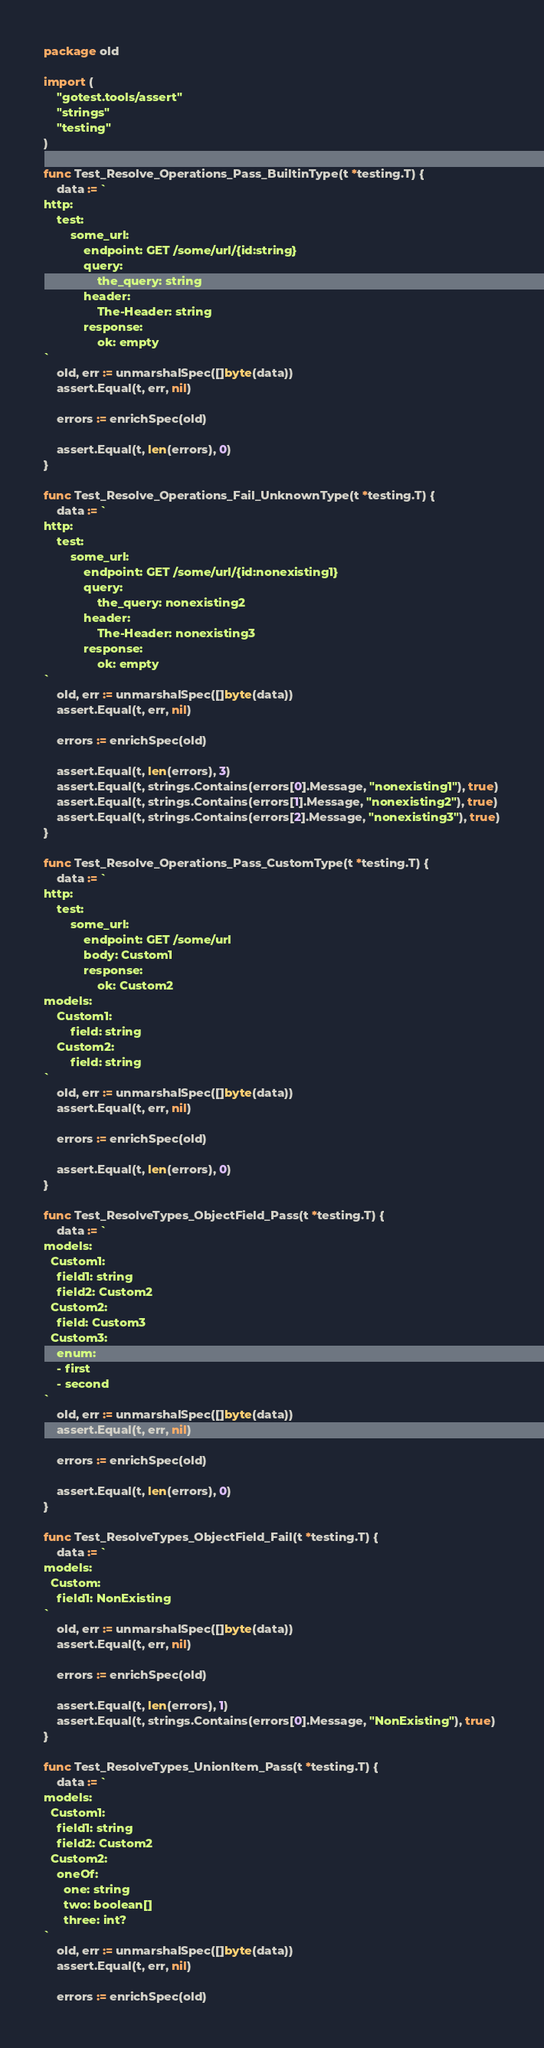<code> <loc_0><loc_0><loc_500><loc_500><_Go_>package old

import (
	"gotest.tools/assert"
	"strings"
	"testing"
)

func Test_Resolve_Operations_Pass_BuiltinType(t *testing.T) {
	data := `
http:
    test:
        some_url:
            endpoint: GET /some/url/{id:string}
            query:
                the_query: string
            header:
                The-Header: string
            response:
                ok: empty
`
	old, err := unmarshalSpec([]byte(data))
	assert.Equal(t, err, nil)

	errors := enrichSpec(old)

	assert.Equal(t, len(errors), 0)
}

func Test_Resolve_Operations_Fail_UnknownType(t *testing.T) {
	data := `
http:
    test:
        some_url:
            endpoint: GET /some/url/{id:nonexisting1}
            query:
                the_query: nonexisting2
            header:
                The-Header: nonexisting3
            response:
                ok: empty
`
	old, err := unmarshalSpec([]byte(data))
	assert.Equal(t, err, nil)

	errors := enrichSpec(old)

	assert.Equal(t, len(errors), 3)
	assert.Equal(t, strings.Contains(errors[0].Message, "nonexisting1"), true)
	assert.Equal(t, strings.Contains(errors[1].Message, "nonexisting2"), true)
	assert.Equal(t, strings.Contains(errors[2].Message, "nonexisting3"), true)
}

func Test_Resolve_Operations_Pass_CustomType(t *testing.T) {
	data := `
http:
    test:
        some_url:
            endpoint: GET /some/url
            body: Custom1
            response:
                ok: Custom2
models:
    Custom1:
        field: string
    Custom2:
        field: string
`
	old, err := unmarshalSpec([]byte(data))
	assert.Equal(t, err, nil)

	errors := enrichSpec(old)

	assert.Equal(t, len(errors), 0)
}

func Test_ResolveTypes_ObjectField_Pass(t *testing.T) {
	data := `
models:
  Custom1:
    field1: string
    field2: Custom2
  Custom2:
    field: Custom3
  Custom3:
    enum:
    - first
    - second
`
	old, err := unmarshalSpec([]byte(data))
	assert.Equal(t, err, nil)

	errors := enrichSpec(old)

	assert.Equal(t, len(errors), 0)
}

func Test_ResolveTypes_ObjectField_Fail(t *testing.T) {
	data := `
models:
  Custom:
    field1: NonExisting
`
	old, err := unmarshalSpec([]byte(data))
	assert.Equal(t, err, nil)

	errors := enrichSpec(old)

	assert.Equal(t, len(errors), 1)
	assert.Equal(t, strings.Contains(errors[0].Message, "NonExisting"), true)
}

func Test_ResolveTypes_UnionItem_Pass(t *testing.T) {
	data := `
models:
  Custom1:
    field1: string
    field2: Custom2
  Custom2:
    oneOf:
      one: string
      two: boolean[]
      three: int?
`
	old, err := unmarshalSpec([]byte(data))
	assert.Equal(t, err, nil)

	errors := enrichSpec(old)
</code> 